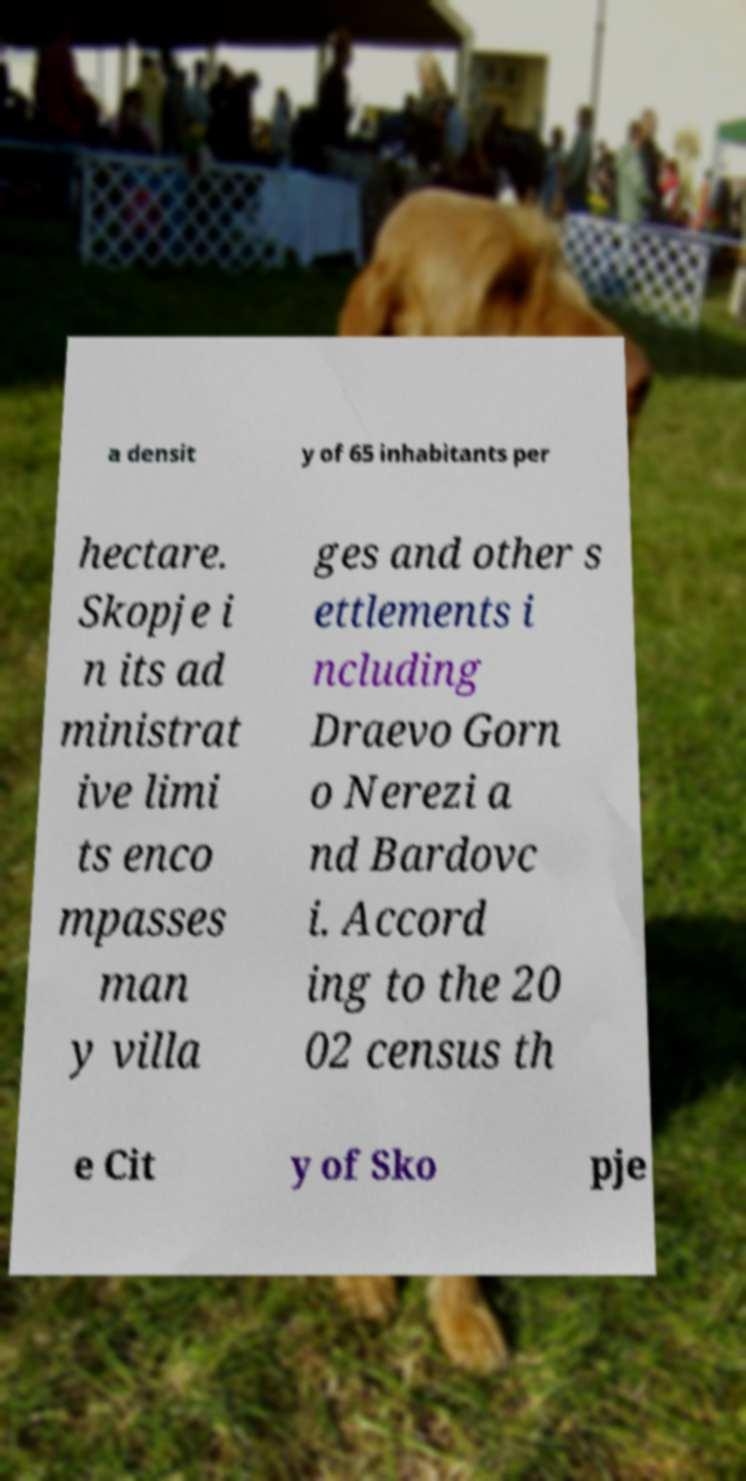Could you extract and type out the text from this image? a densit y of 65 inhabitants per hectare. Skopje i n its ad ministrat ive limi ts enco mpasses man y villa ges and other s ettlements i ncluding Draevo Gorn o Nerezi a nd Bardovc i. Accord ing to the 20 02 census th e Cit y of Sko pje 